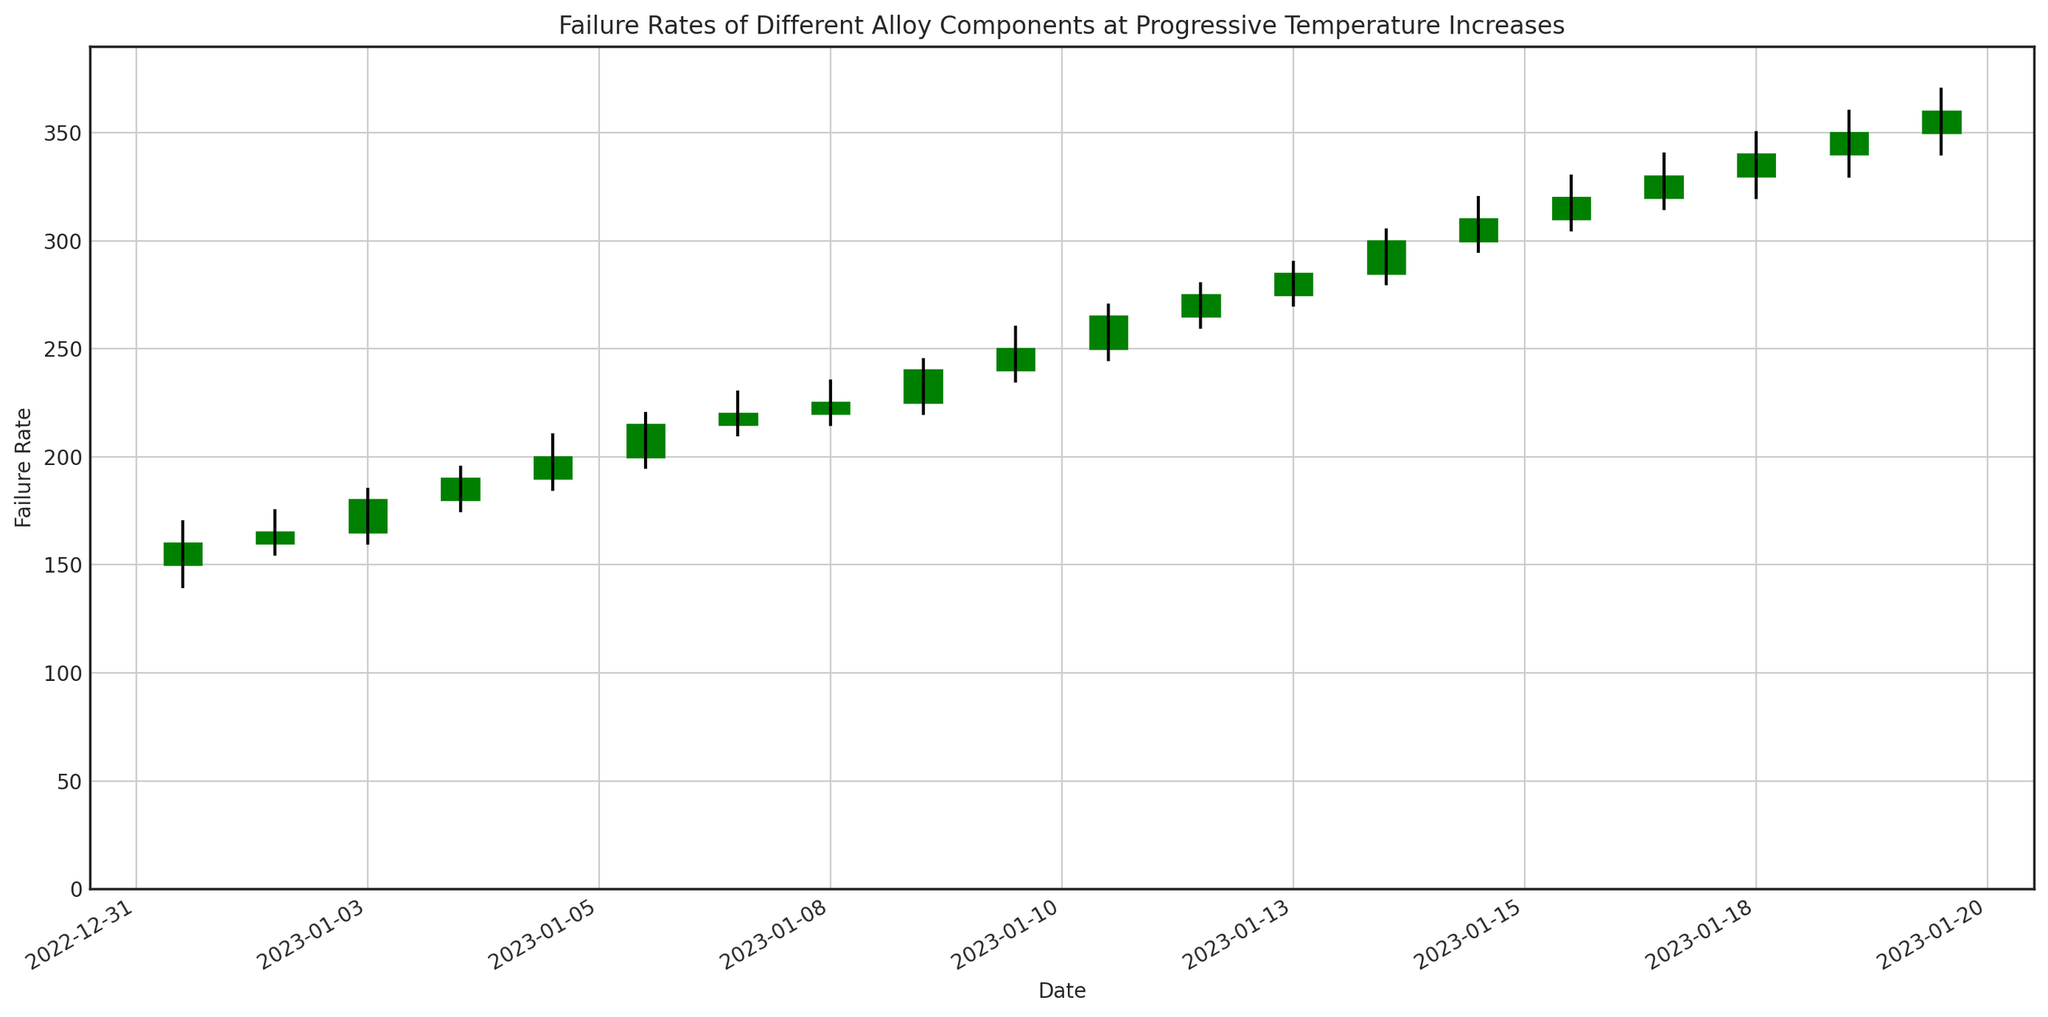What date showed the highest high value? The highest high value shown in the chart is 370. By visually scanning the figure, we find this peak on January 20, 2023.
Answer: January 20, 2023 Which date had a higher close value: January 5, 2023, or January 10, 2023? To determine which date had a higher close value, compare the close values for January 5 (200) and January 10 (250). January 10 has the higher close value.
Answer: January 10, 2023 What is the range of failure rates on January 15, 2023? The range is calculated as the difference between the high and low values. For January 15, this corresponds to 320 - 295 = 25.
Answer: 25 Did any date show a drop in the closing value compared to the previous date? If so, name one. Scan the figure to see if any red bars indicate a decrease in closing value from one day to the next. January 2 shows a decrease from January 1 (160 to 165).*
Answer: January 2, 2023 Between January 7 and January 10, which date shows the smallest difference between the high and low values? Calculate the differences between the high and low values for each day: January 7 (230-210 = 20), January 8 (235-215 = 20), January 9 (245-220 = 25), and January 10 (260-235 = 25). The smallest differences are on January 7 and January 8.
Answer: January 7, 2023, and January 8, 2023 What is the overall trend in closing values from January 1 to January 20? The trend can be observed by following the closing values from January 1 (160) to January 20 (360). The closing values show a progressive increase throughout the duration.
Answer: Increasing On which date did the component show the biggest increase in closing value compared to the previous date? The most significant increase in closing value can be found by evaluating the differences between consecutive dates. The largest increase is observed between January 12 (275) and January 13 (285), with a difference of 10 units.
Answer: January 13, 2023 What visual indicates that the closing value on a specific date is higher than the opening value? A green candle indicates that the closing value is higher than the opening value.
Answer: Green candles What were the high and low values for January 18, 2023? From the figure, the high is the upper limit of the wick and the low is the lower limit of the wick. For January 18, the high is 350 and the low is 320.
Answer: High: 350, Low: 320 